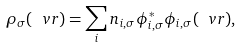Convert formula to latex. <formula><loc_0><loc_0><loc_500><loc_500>\rho _ { \sigma } ( \ v r ) = \sum _ { i } n _ { i , \sigma } \phi _ { i , \sigma } ^ { * } \phi _ { i , \sigma } ( \ v r ) ,</formula> 